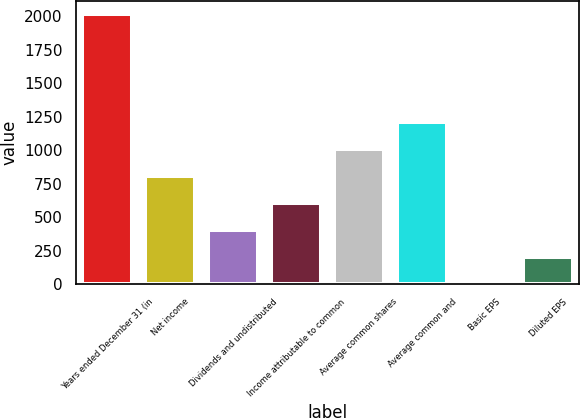Convert chart to OTSL. <chart><loc_0><loc_0><loc_500><loc_500><bar_chart><fcel>Years ended December 31 (in<fcel>Net income<fcel>Dividends and undistributed<fcel>Income attributable to common<fcel>Average common shares<fcel>Average common and<fcel>Basic EPS<fcel>Diluted EPS<nl><fcel>2013<fcel>805.66<fcel>403.2<fcel>604.43<fcel>1006.89<fcel>1208.12<fcel>0.74<fcel>201.97<nl></chart> 